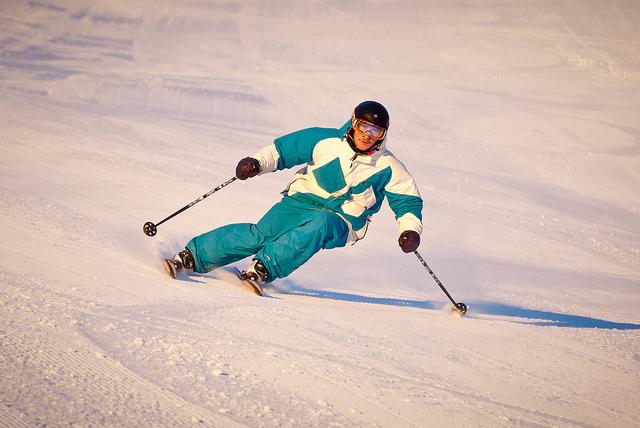What color is the ground?
Give a very brief answer. White. What is the man doing?
Keep it brief. Skiing. Is this man turning?
Write a very short answer. Yes. 